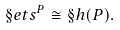Convert formula to latex. <formula><loc_0><loc_0><loc_500><loc_500>\S e t s ^ { P } \cong \S h ( P ) .</formula> 